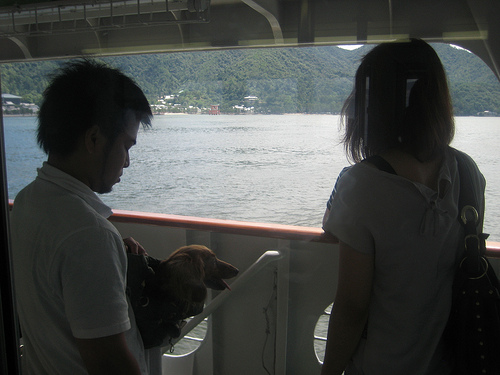<image>
Is there a dog in front of the man? Yes. The dog is positioned in front of the man, appearing closer to the camera viewpoint. 